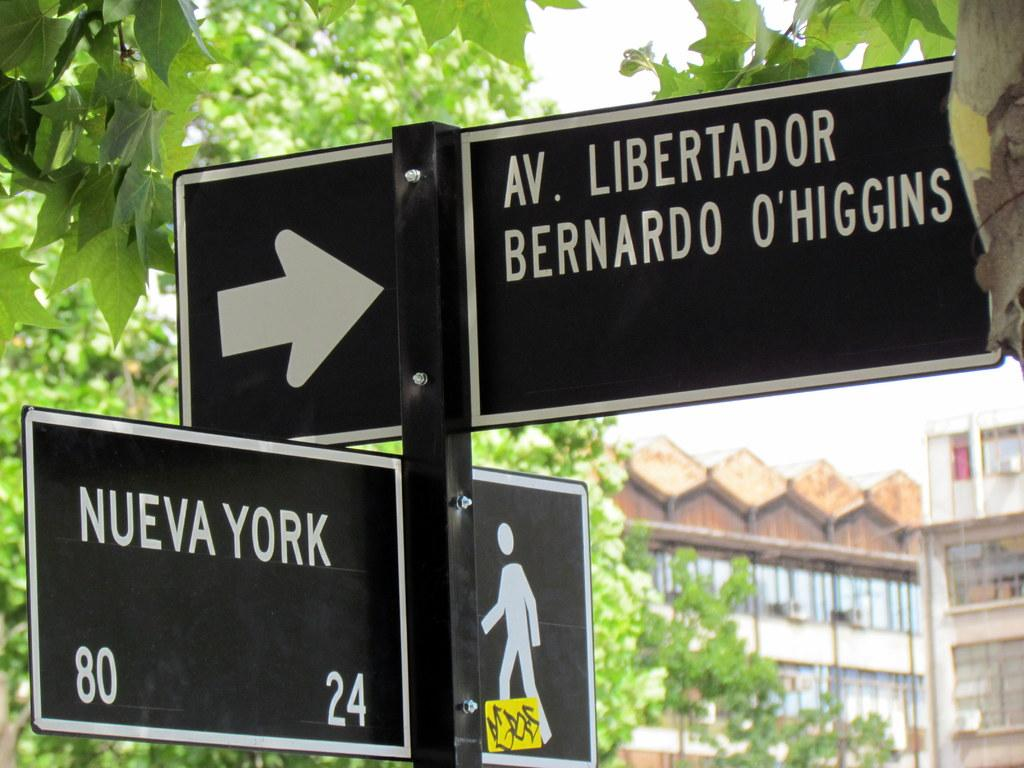What is attached to the poles and trees in the image? There are boards attached to poles and trees in the image. What can be seen in the distance behind the boards? There are buildings visible in the background of the image. What is visible above the buildings in the image? The sky is visible in the background of the image. Where is the gun located in the image? There is no gun present in the image. What type of idea is being discussed in the image? There is no indication of a discussion or idea in the image; it primarily features boards attached to poles and trees. 